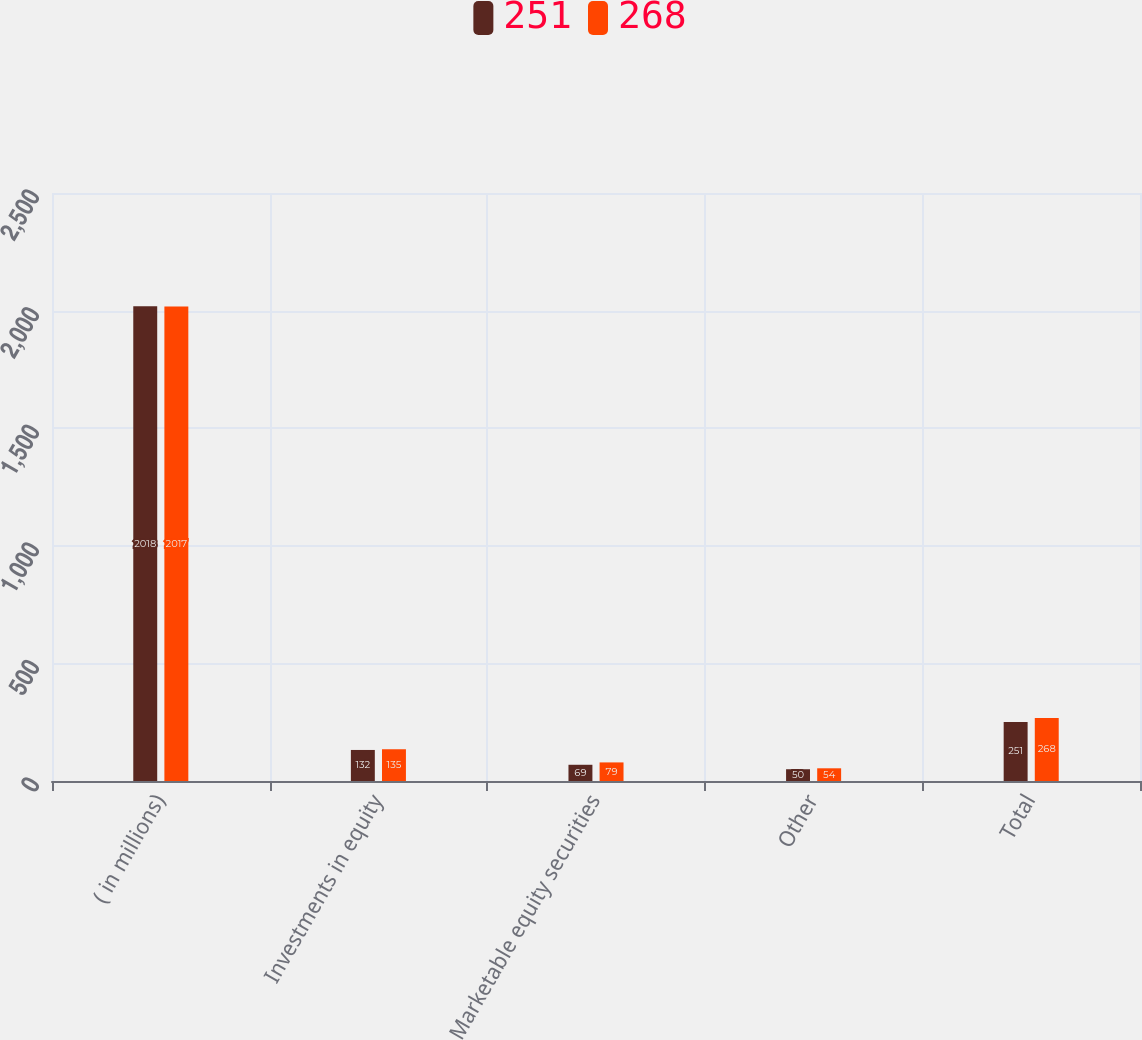Convert chart. <chart><loc_0><loc_0><loc_500><loc_500><stacked_bar_chart><ecel><fcel>( in millions)<fcel>Investments in equity<fcel>Marketable equity securities<fcel>Other<fcel>Total<nl><fcel>251<fcel>2018<fcel>132<fcel>69<fcel>50<fcel>251<nl><fcel>268<fcel>2017<fcel>135<fcel>79<fcel>54<fcel>268<nl></chart> 